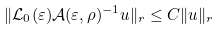<formula> <loc_0><loc_0><loc_500><loc_500>\| \mathcal { L } _ { 0 } ( \varepsilon ) \mathcal { A } ( \varepsilon , \rho ) ^ { - 1 } u \| _ { \L r } \leq C \| u \| _ { \L r }</formula> 